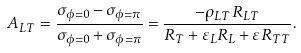<formula> <loc_0><loc_0><loc_500><loc_500>A _ { L T } = \frac { \sigma _ { \phi = 0 } - \sigma _ { \phi = \pi } } { \sigma _ { \phi = 0 } + \sigma _ { \phi = \pi } } = \frac { - \rho _ { L T } R _ { L T } } { R _ { T } + \varepsilon _ { L } R _ { L } + \varepsilon R _ { T T } } .</formula> 